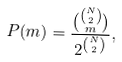Convert formula to latex. <formula><loc_0><loc_0><loc_500><loc_500>P ( m ) = \frac { { { N \choose 2 } \choose m } } { 2 ^ { N \choose 2 } } ,</formula> 